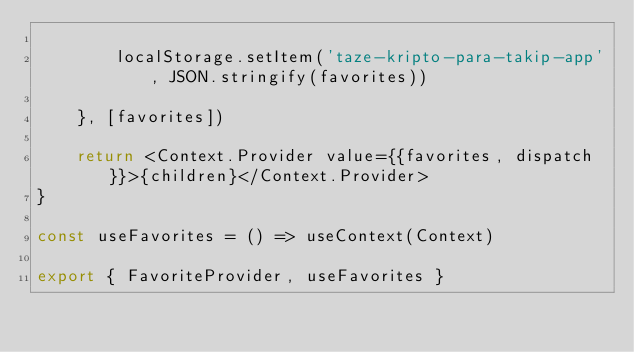<code> <loc_0><loc_0><loc_500><loc_500><_JavaScript_>
        localStorage.setItem('taze-kripto-para-takip-app', JSON.stringify(favorites))
        
    }, [favorites])

    return <Context.Provider value={{favorites, dispatch}}>{children}</Context.Provider>
}

const useFavorites = () => useContext(Context)

export { FavoriteProvider, useFavorites }</code> 